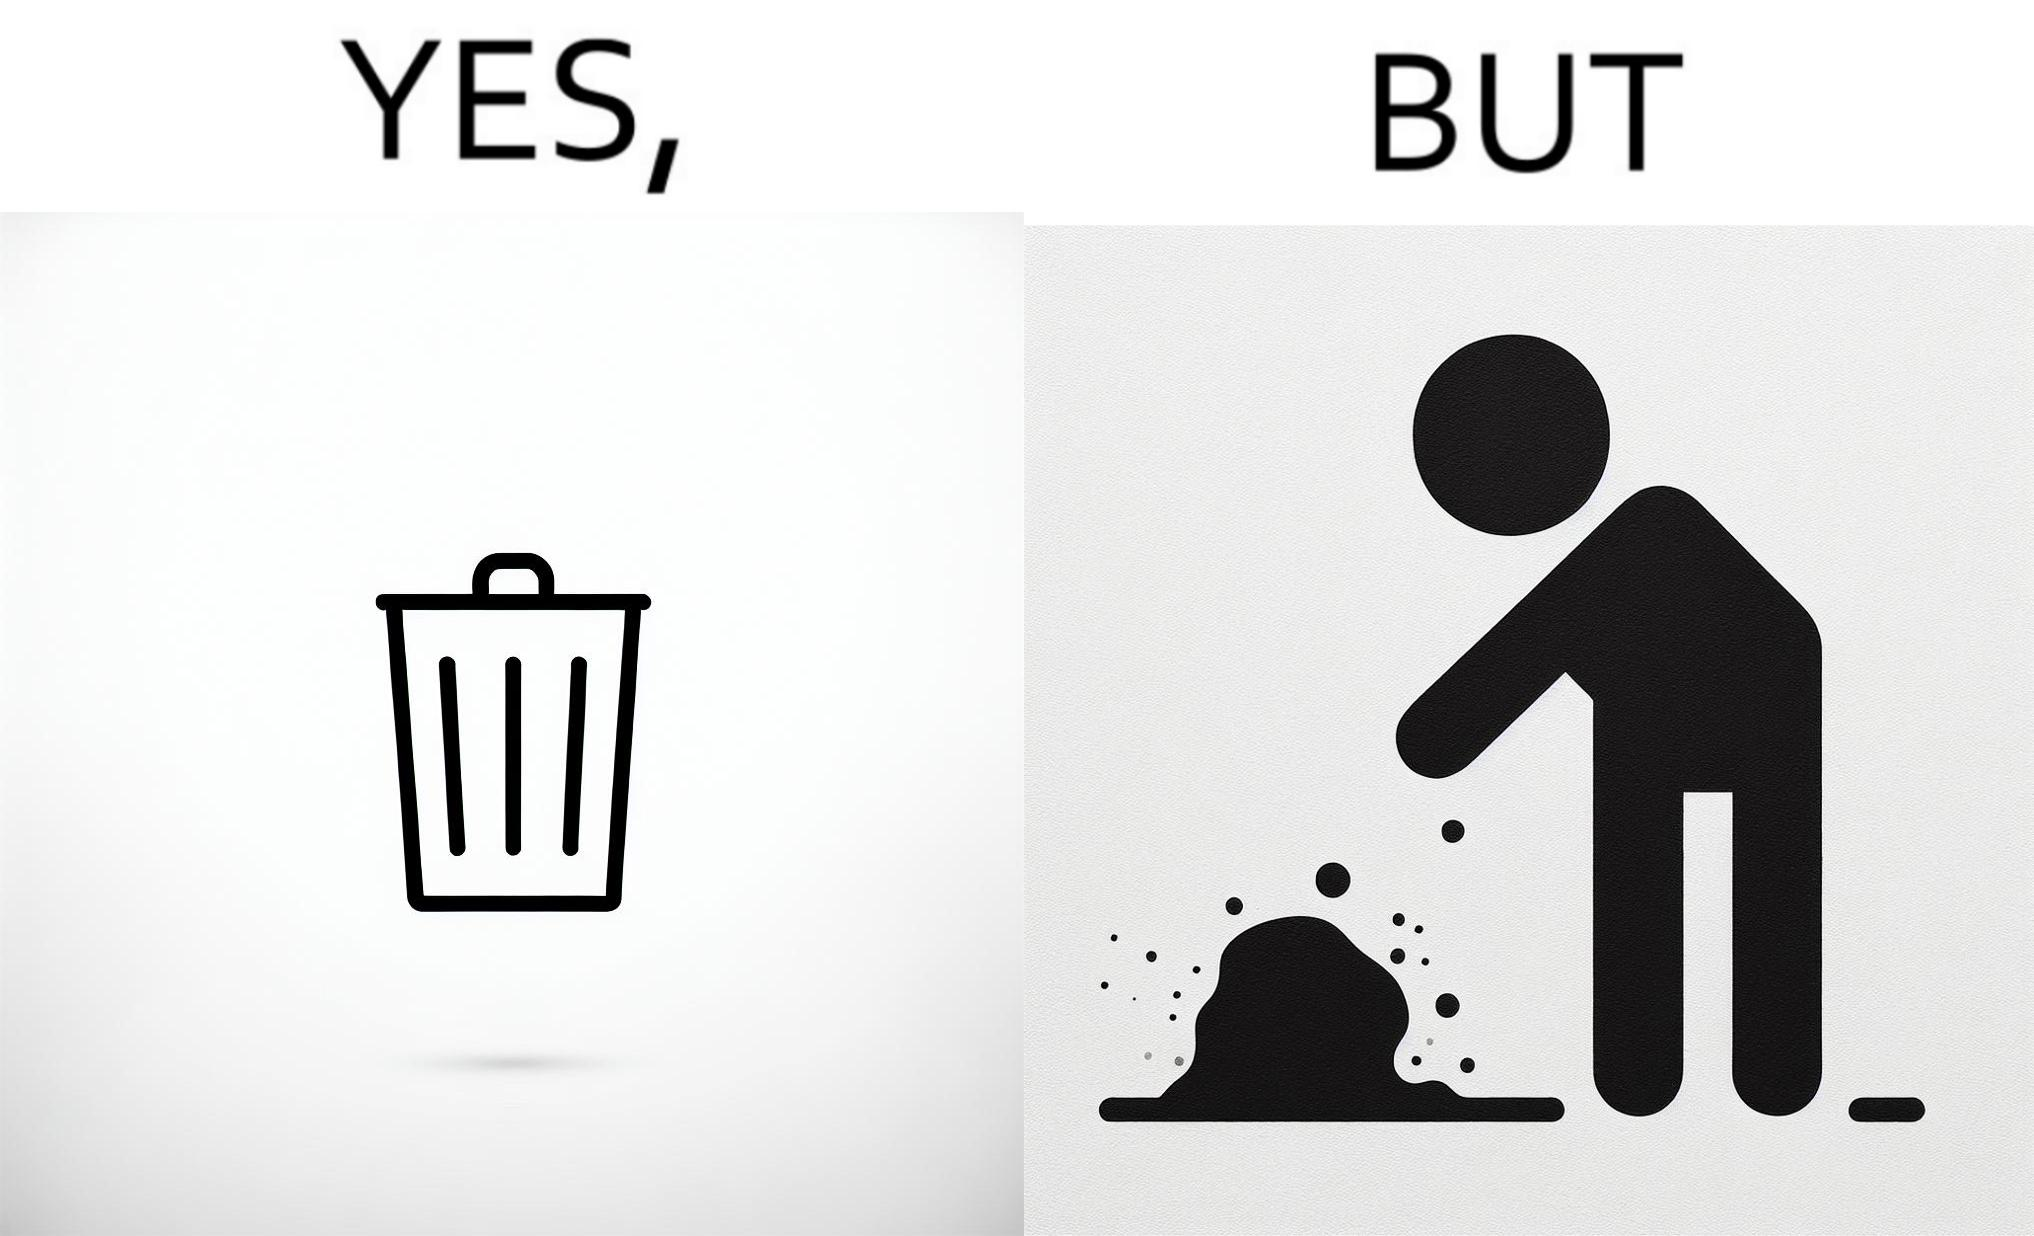What does this image depict? The images are ironic because even though garbage bins are provided for humans to dispose waste, by habit humans still choose to make surroundings dirty by disposing garbage improperly 